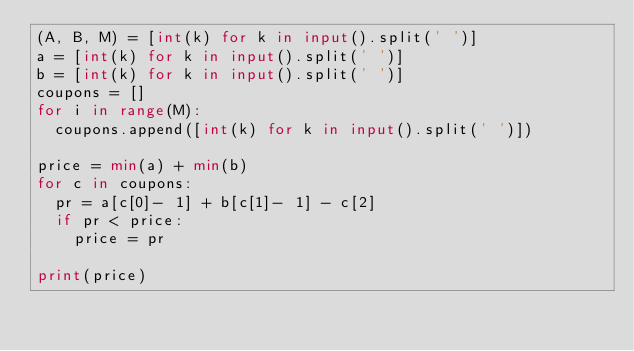<code> <loc_0><loc_0><loc_500><loc_500><_Python_>(A, B, M) = [int(k) for k in input().split(' ')]
a = [int(k) for k in input().split(' ')]
b = [int(k) for k in input().split(' ')]
coupons = []
for i in range(M):
  coupons.append([int(k) for k in input().split(' ')])

price = min(a) + min(b)
for c in coupons:
  pr = a[c[0]- 1] + b[c[1]- 1] - c[2]
  if pr < price:
    price = pr

print(price)</code> 